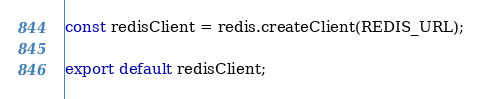<code> <loc_0><loc_0><loc_500><loc_500><_TypeScript_>const redisClient = redis.createClient(REDIS_URL);

export default redisClient;
</code> 